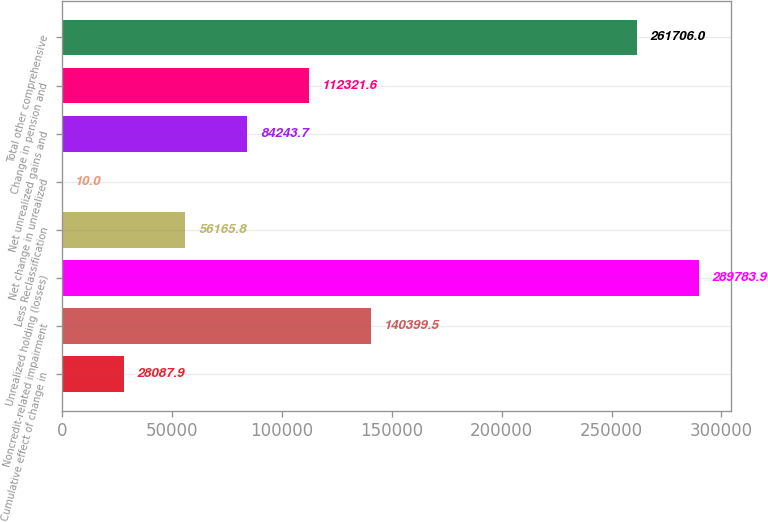Convert chart to OTSL. <chart><loc_0><loc_0><loc_500><loc_500><bar_chart><fcel>Cumulative effect of change in<fcel>Noncredit-related impairment<fcel>Unrealized holding (losses)<fcel>Less Reclassification<fcel>Net change in unrealized<fcel>Net unrealized gains and<fcel>Change in pension and<fcel>Total other comprehensive<nl><fcel>28087.9<fcel>140400<fcel>289784<fcel>56165.8<fcel>10<fcel>84243.7<fcel>112322<fcel>261706<nl></chart> 